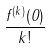<formula> <loc_0><loc_0><loc_500><loc_500>\frac { f ^ { ( k ) } ( 0 ) } { k ! }</formula> 